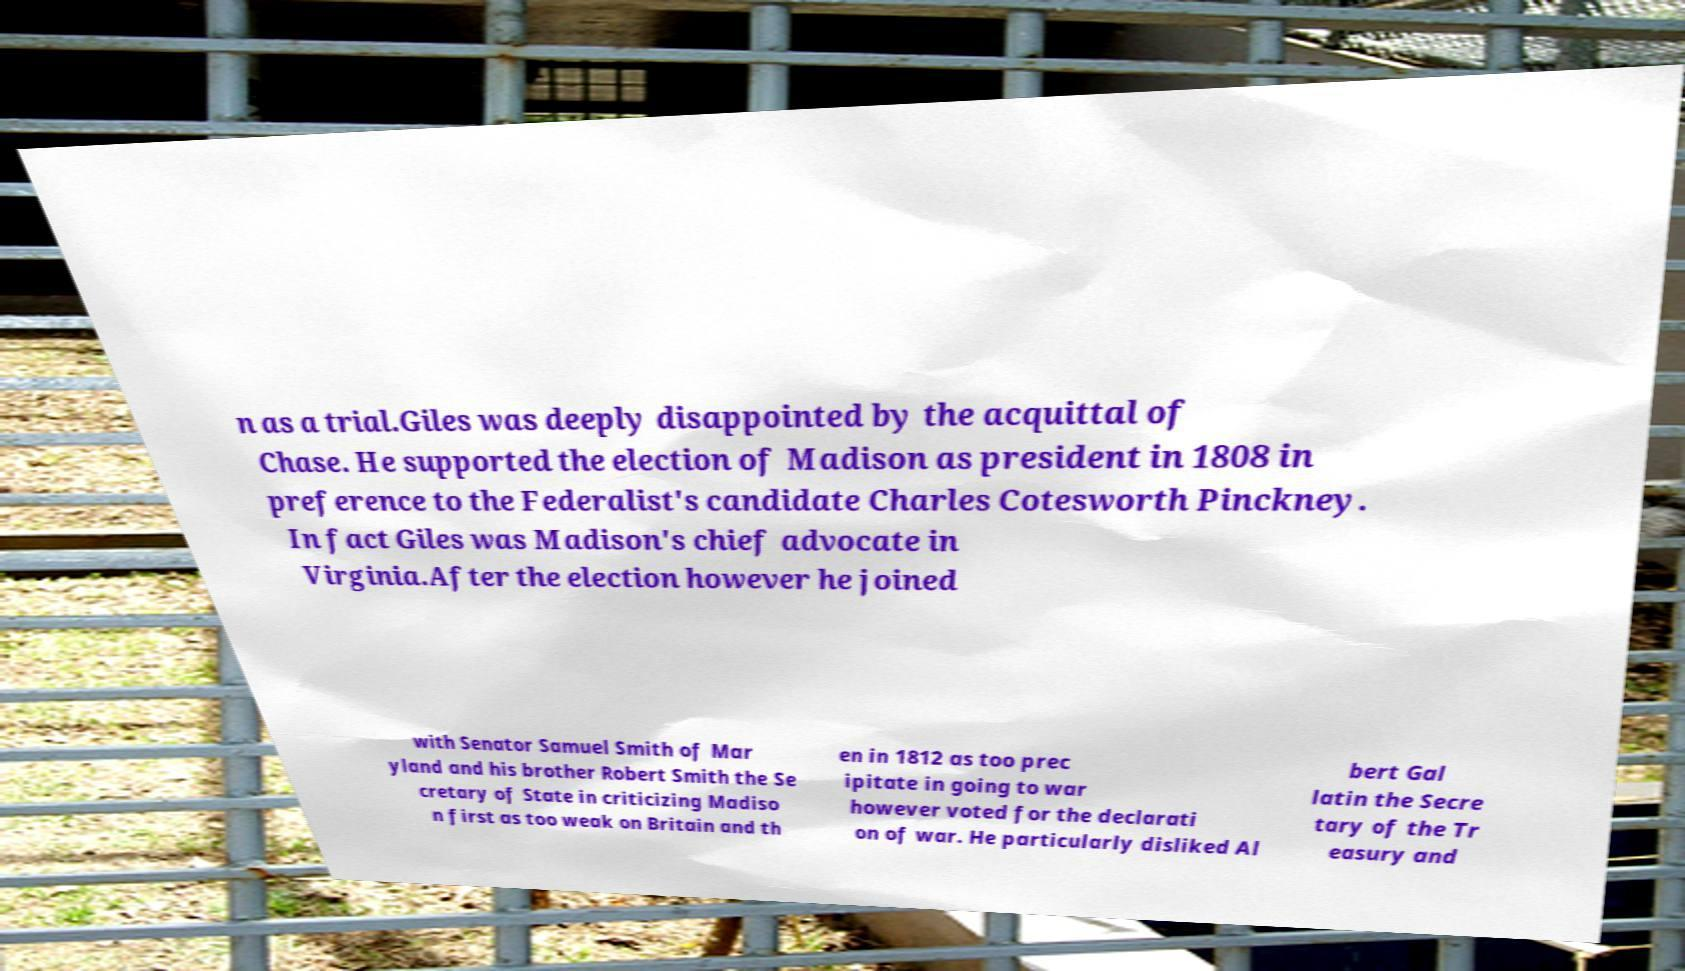For documentation purposes, I need the text within this image transcribed. Could you provide that? n as a trial.Giles was deeply disappointed by the acquittal of Chase. He supported the election of Madison as president in 1808 in preference to the Federalist's candidate Charles Cotesworth Pinckney. In fact Giles was Madison's chief advocate in Virginia.After the election however he joined with Senator Samuel Smith of Mar yland and his brother Robert Smith the Se cretary of State in criticizing Madiso n first as too weak on Britain and th en in 1812 as too prec ipitate in going to war however voted for the declarati on of war. He particularly disliked Al bert Gal latin the Secre tary of the Tr easury and 